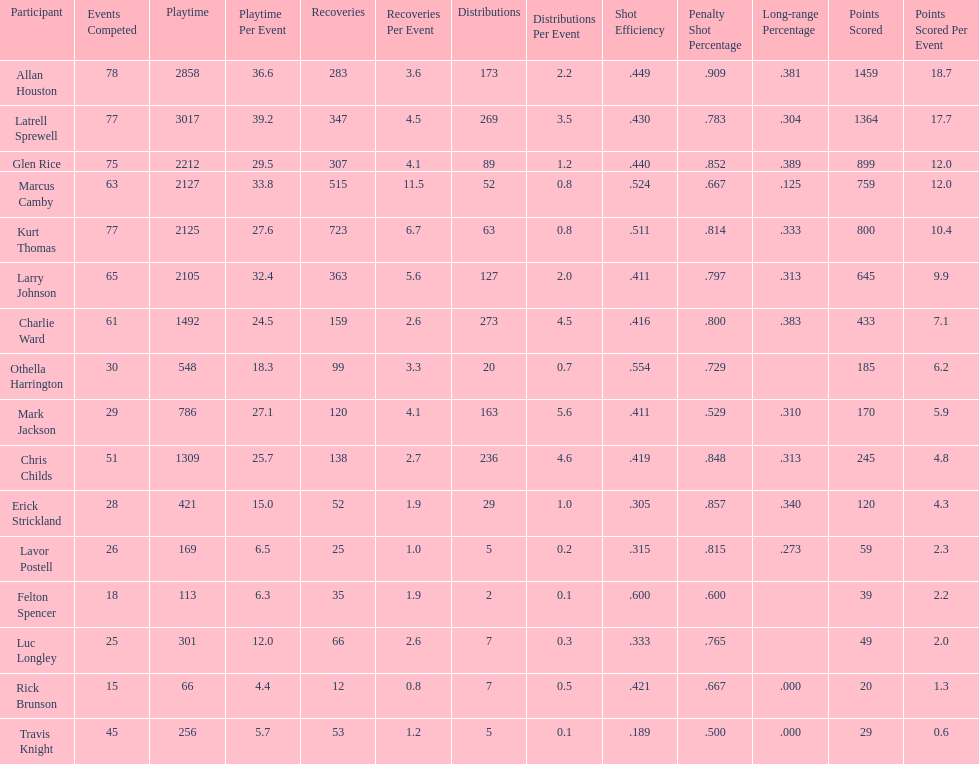How many total points were scored by players averaging over 4 assists per game> 848. 